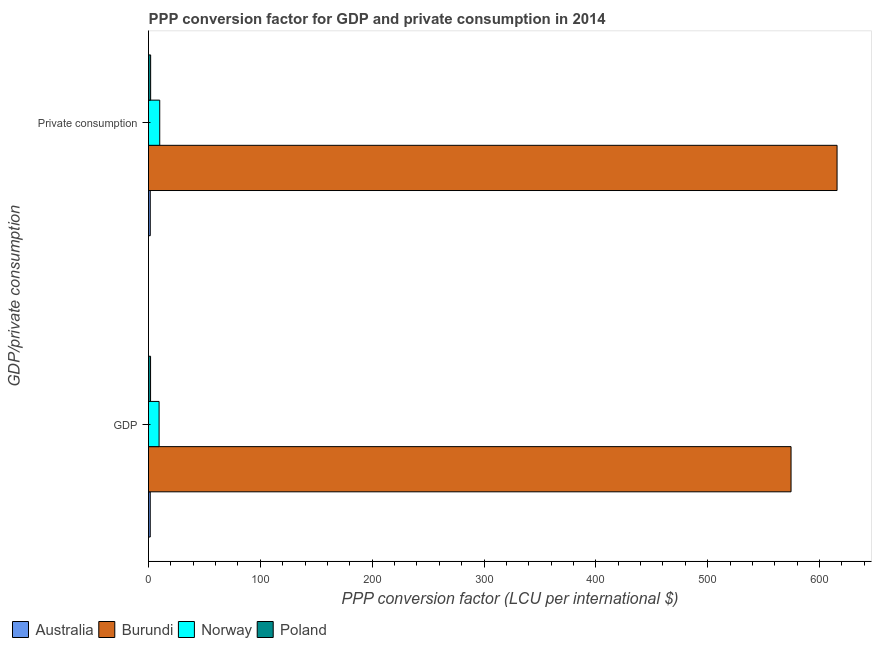How many different coloured bars are there?
Your answer should be compact. 4. How many bars are there on the 1st tick from the top?
Provide a succinct answer. 4. How many bars are there on the 1st tick from the bottom?
Your answer should be very brief. 4. What is the label of the 2nd group of bars from the top?
Offer a terse response. GDP. What is the ppp conversion factor for gdp in Australia?
Your response must be concise. 1.54. Across all countries, what is the maximum ppp conversion factor for gdp?
Give a very brief answer. 574.58. Across all countries, what is the minimum ppp conversion factor for gdp?
Offer a very short reply. 1.54. In which country was the ppp conversion factor for private consumption maximum?
Your answer should be very brief. Burundi. In which country was the ppp conversion factor for gdp minimum?
Your response must be concise. Australia. What is the total ppp conversion factor for gdp in the graph?
Offer a very short reply. 587.4. What is the difference between the ppp conversion factor for private consumption in Norway and that in Poland?
Provide a succinct answer. 8.13. What is the difference between the ppp conversion factor for private consumption in Burundi and the ppp conversion factor for gdp in Australia?
Offer a terse response. 614.2. What is the average ppp conversion factor for gdp per country?
Your answer should be compact. 146.85. What is the difference between the ppp conversion factor for gdp and ppp conversion factor for private consumption in Poland?
Ensure brevity in your answer.  -0.06. In how many countries, is the ppp conversion factor for gdp greater than 500 LCU?
Your response must be concise. 1. What is the ratio of the ppp conversion factor for private consumption in Poland to that in Norway?
Your response must be concise. 0.19. What does the 2nd bar from the top in GDP represents?
Your answer should be compact. Norway. What does the 3rd bar from the bottom in GDP represents?
Offer a terse response. Norway. How many bars are there?
Provide a short and direct response. 8. Are all the bars in the graph horizontal?
Offer a terse response. Yes. What is the difference between two consecutive major ticks on the X-axis?
Offer a terse response. 100. Where does the legend appear in the graph?
Your answer should be compact. Bottom left. What is the title of the graph?
Your response must be concise. PPP conversion factor for GDP and private consumption in 2014. What is the label or title of the X-axis?
Make the answer very short. PPP conversion factor (LCU per international $). What is the label or title of the Y-axis?
Offer a terse response. GDP/private consumption. What is the PPP conversion factor (LCU per international $) in Australia in GDP?
Provide a succinct answer. 1.54. What is the PPP conversion factor (LCU per international $) of Burundi in GDP?
Your answer should be compact. 574.58. What is the PPP conversion factor (LCU per international $) of Norway in GDP?
Your answer should be compact. 9.45. What is the PPP conversion factor (LCU per international $) of Poland in GDP?
Your response must be concise. 1.83. What is the PPP conversion factor (LCU per international $) in Australia in  Private consumption?
Give a very brief answer. 1.55. What is the PPP conversion factor (LCU per international $) in Burundi in  Private consumption?
Make the answer very short. 615.73. What is the PPP conversion factor (LCU per international $) in Norway in  Private consumption?
Your answer should be compact. 10.02. What is the PPP conversion factor (LCU per international $) in Poland in  Private consumption?
Provide a short and direct response. 1.89. Across all GDP/private consumption, what is the maximum PPP conversion factor (LCU per international $) of Australia?
Provide a succinct answer. 1.55. Across all GDP/private consumption, what is the maximum PPP conversion factor (LCU per international $) of Burundi?
Make the answer very short. 615.73. Across all GDP/private consumption, what is the maximum PPP conversion factor (LCU per international $) of Norway?
Your answer should be compact. 10.02. Across all GDP/private consumption, what is the maximum PPP conversion factor (LCU per international $) of Poland?
Give a very brief answer. 1.89. Across all GDP/private consumption, what is the minimum PPP conversion factor (LCU per international $) in Australia?
Your answer should be compact. 1.54. Across all GDP/private consumption, what is the minimum PPP conversion factor (LCU per international $) in Burundi?
Provide a succinct answer. 574.58. Across all GDP/private consumption, what is the minimum PPP conversion factor (LCU per international $) in Norway?
Make the answer very short. 9.45. Across all GDP/private consumption, what is the minimum PPP conversion factor (LCU per international $) of Poland?
Provide a short and direct response. 1.83. What is the total PPP conversion factor (LCU per international $) in Australia in the graph?
Your answer should be very brief. 3.09. What is the total PPP conversion factor (LCU per international $) in Burundi in the graph?
Offer a very short reply. 1190.31. What is the total PPP conversion factor (LCU per international $) of Norway in the graph?
Make the answer very short. 19.48. What is the total PPP conversion factor (LCU per international $) of Poland in the graph?
Your answer should be very brief. 3.72. What is the difference between the PPP conversion factor (LCU per international $) in Australia in GDP and that in  Private consumption?
Your response must be concise. -0.02. What is the difference between the PPP conversion factor (LCU per international $) of Burundi in GDP and that in  Private consumption?
Ensure brevity in your answer.  -41.16. What is the difference between the PPP conversion factor (LCU per international $) of Norway in GDP and that in  Private consumption?
Offer a very short reply. -0.57. What is the difference between the PPP conversion factor (LCU per international $) of Poland in GDP and that in  Private consumption?
Ensure brevity in your answer.  -0.06. What is the difference between the PPP conversion factor (LCU per international $) of Australia in GDP and the PPP conversion factor (LCU per international $) of Burundi in  Private consumption?
Provide a succinct answer. -614.2. What is the difference between the PPP conversion factor (LCU per international $) in Australia in GDP and the PPP conversion factor (LCU per international $) in Norway in  Private consumption?
Keep it short and to the point. -8.49. What is the difference between the PPP conversion factor (LCU per international $) in Australia in GDP and the PPP conversion factor (LCU per international $) in Poland in  Private consumption?
Your answer should be very brief. -0.36. What is the difference between the PPP conversion factor (LCU per international $) of Burundi in GDP and the PPP conversion factor (LCU per international $) of Norway in  Private consumption?
Your answer should be compact. 564.55. What is the difference between the PPP conversion factor (LCU per international $) of Burundi in GDP and the PPP conversion factor (LCU per international $) of Poland in  Private consumption?
Provide a short and direct response. 572.68. What is the difference between the PPP conversion factor (LCU per international $) in Norway in GDP and the PPP conversion factor (LCU per international $) in Poland in  Private consumption?
Make the answer very short. 7.56. What is the average PPP conversion factor (LCU per international $) in Australia per GDP/private consumption?
Offer a very short reply. 1.54. What is the average PPP conversion factor (LCU per international $) of Burundi per GDP/private consumption?
Keep it short and to the point. 595.15. What is the average PPP conversion factor (LCU per international $) of Norway per GDP/private consumption?
Your answer should be very brief. 9.74. What is the average PPP conversion factor (LCU per international $) in Poland per GDP/private consumption?
Your answer should be compact. 1.86. What is the difference between the PPP conversion factor (LCU per international $) of Australia and PPP conversion factor (LCU per international $) of Burundi in GDP?
Ensure brevity in your answer.  -573.04. What is the difference between the PPP conversion factor (LCU per international $) in Australia and PPP conversion factor (LCU per international $) in Norway in GDP?
Provide a succinct answer. -7.92. What is the difference between the PPP conversion factor (LCU per international $) in Australia and PPP conversion factor (LCU per international $) in Poland in GDP?
Your response must be concise. -0.29. What is the difference between the PPP conversion factor (LCU per international $) in Burundi and PPP conversion factor (LCU per international $) in Norway in GDP?
Offer a terse response. 565.12. What is the difference between the PPP conversion factor (LCU per international $) in Burundi and PPP conversion factor (LCU per international $) in Poland in GDP?
Keep it short and to the point. 572.75. What is the difference between the PPP conversion factor (LCU per international $) of Norway and PPP conversion factor (LCU per international $) of Poland in GDP?
Offer a very short reply. 7.63. What is the difference between the PPP conversion factor (LCU per international $) of Australia and PPP conversion factor (LCU per international $) of Burundi in  Private consumption?
Offer a very short reply. -614.18. What is the difference between the PPP conversion factor (LCU per international $) of Australia and PPP conversion factor (LCU per international $) of Norway in  Private consumption?
Ensure brevity in your answer.  -8.47. What is the difference between the PPP conversion factor (LCU per international $) of Australia and PPP conversion factor (LCU per international $) of Poland in  Private consumption?
Provide a succinct answer. -0.34. What is the difference between the PPP conversion factor (LCU per international $) in Burundi and PPP conversion factor (LCU per international $) in Norway in  Private consumption?
Provide a short and direct response. 605.71. What is the difference between the PPP conversion factor (LCU per international $) of Burundi and PPP conversion factor (LCU per international $) of Poland in  Private consumption?
Give a very brief answer. 613.84. What is the difference between the PPP conversion factor (LCU per international $) in Norway and PPP conversion factor (LCU per international $) in Poland in  Private consumption?
Your response must be concise. 8.13. What is the ratio of the PPP conversion factor (LCU per international $) in Australia in GDP to that in  Private consumption?
Ensure brevity in your answer.  0.99. What is the ratio of the PPP conversion factor (LCU per international $) of Burundi in GDP to that in  Private consumption?
Your response must be concise. 0.93. What is the ratio of the PPP conversion factor (LCU per international $) in Norway in GDP to that in  Private consumption?
Provide a short and direct response. 0.94. What is the ratio of the PPP conversion factor (LCU per international $) in Poland in GDP to that in  Private consumption?
Give a very brief answer. 0.97. What is the difference between the highest and the second highest PPP conversion factor (LCU per international $) of Australia?
Offer a terse response. 0.02. What is the difference between the highest and the second highest PPP conversion factor (LCU per international $) of Burundi?
Ensure brevity in your answer.  41.16. What is the difference between the highest and the second highest PPP conversion factor (LCU per international $) of Norway?
Ensure brevity in your answer.  0.57. What is the difference between the highest and the second highest PPP conversion factor (LCU per international $) of Poland?
Provide a succinct answer. 0.06. What is the difference between the highest and the lowest PPP conversion factor (LCU per international $) of Australia?
Your response must be concise. 0.02. What is the difference between the highest and the lowest PPP conversion factor (LCU per international $) of Burundi?
Give a very brief answer. 41.16. What is the difference between the highest and the lowest PPP conversion factor (LCU per international $) in Norway?
Your answer should be compact. 0.57. What is the difference between the highest and the lowest PPP conversion factor (LCU per international $) of Poland?
Provide a short and direct response. 0.06. 